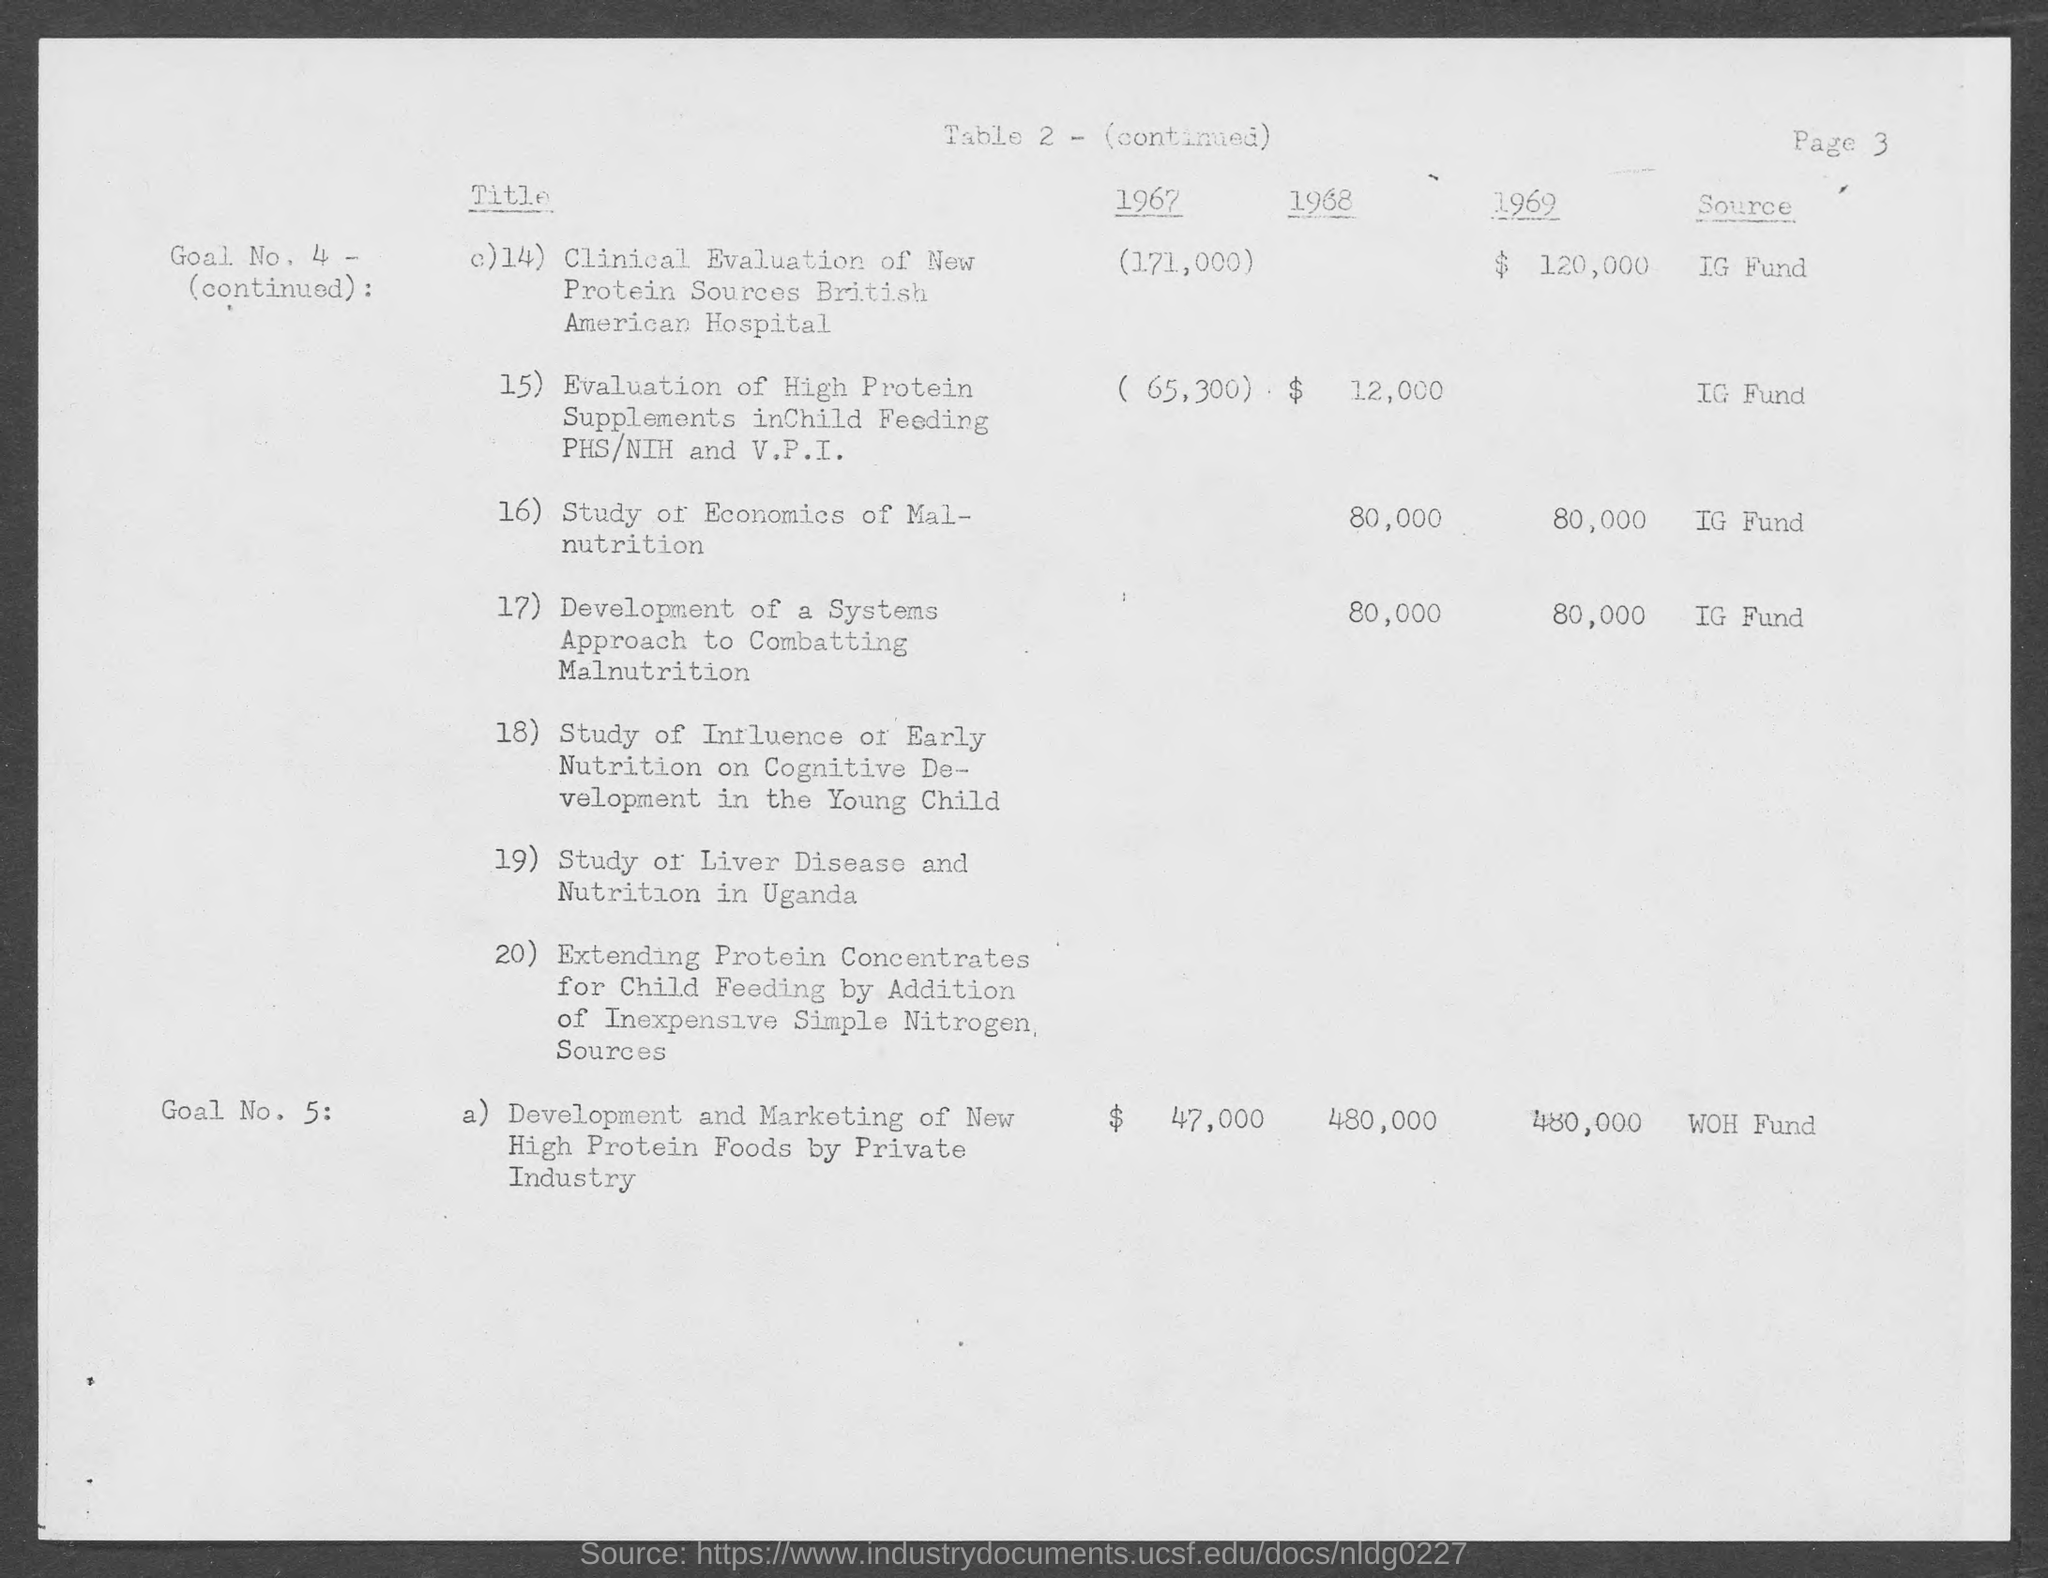What is the cost of Development and marketing of new high protein foods by Private Industry in the year 1967?
Your answer should be very brief. 47,000. What is the source of fund for study of economics of Malnutrition?
Give a very brief answer. IG Fund. What is the source of fund for Development and marketing of new high protein foods by Private Industry?
Ensure brevity in your answer.  WOH Fund. What is the cost for clinical evaluation of new protein sources British American Hospital in the year 1969?
Provide a short and direct response. 120,000. What is the source of fund for clinical evaluation of new protein sources British American Hospital?
Your response must be concise. IG Fund. 